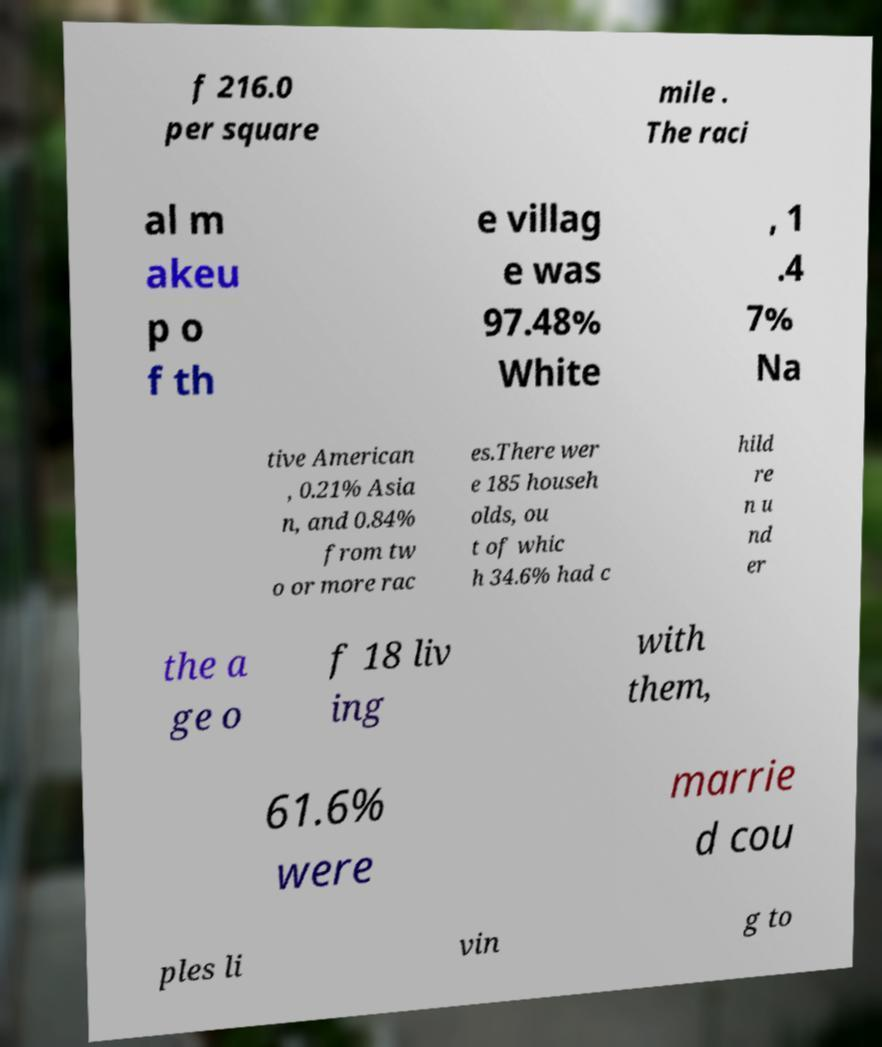Could you assist in decoding the text presented in this image and type it out clearly? f 216.0 per square mile . The raci al m akeu p o f th e villag e was 97.48% White , 1 .4 7% Na tive American , 0.21% Asia n, and 0.84% from tw o or more rac es.There wer e 185 househ olds, ou t of whic h 34.6% had c hild re n u nd er the a ge o f 18 liv ing with them, 61.6% were marrie d cou ples li vin g to 